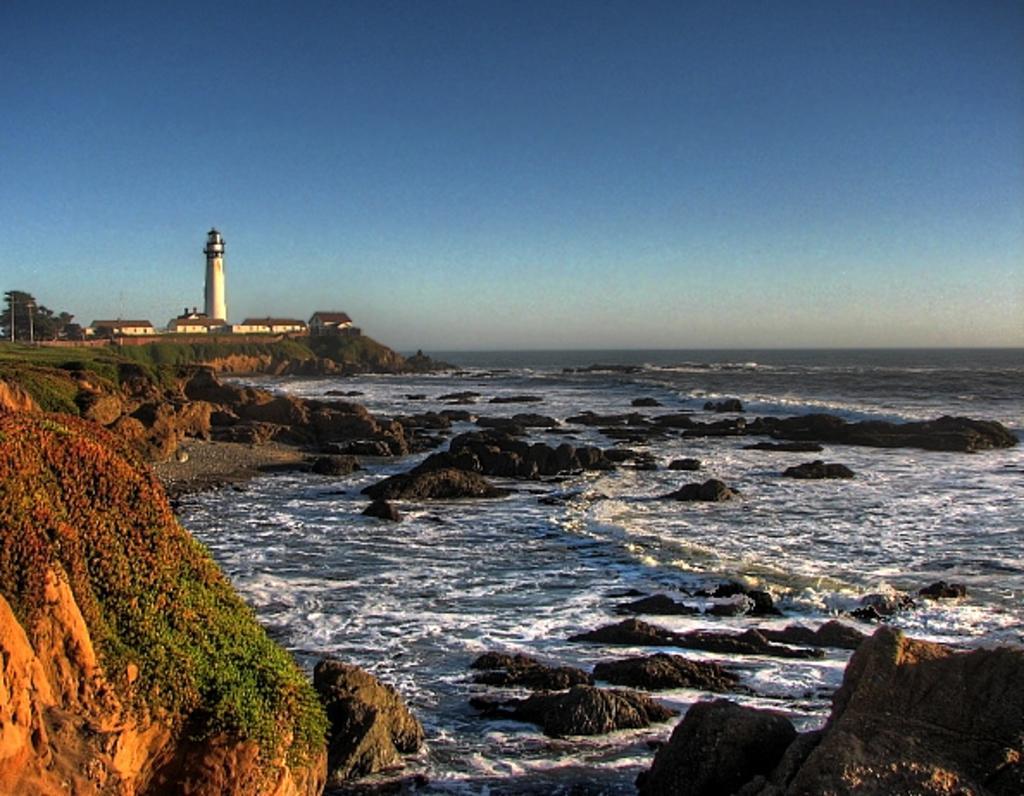Please provide a concise description of this image. In the foreground of this image, on the left there is a rock and the water. In the background, there are rocks, water, a lighthouse, few buildings, trees, poles and the sky. 